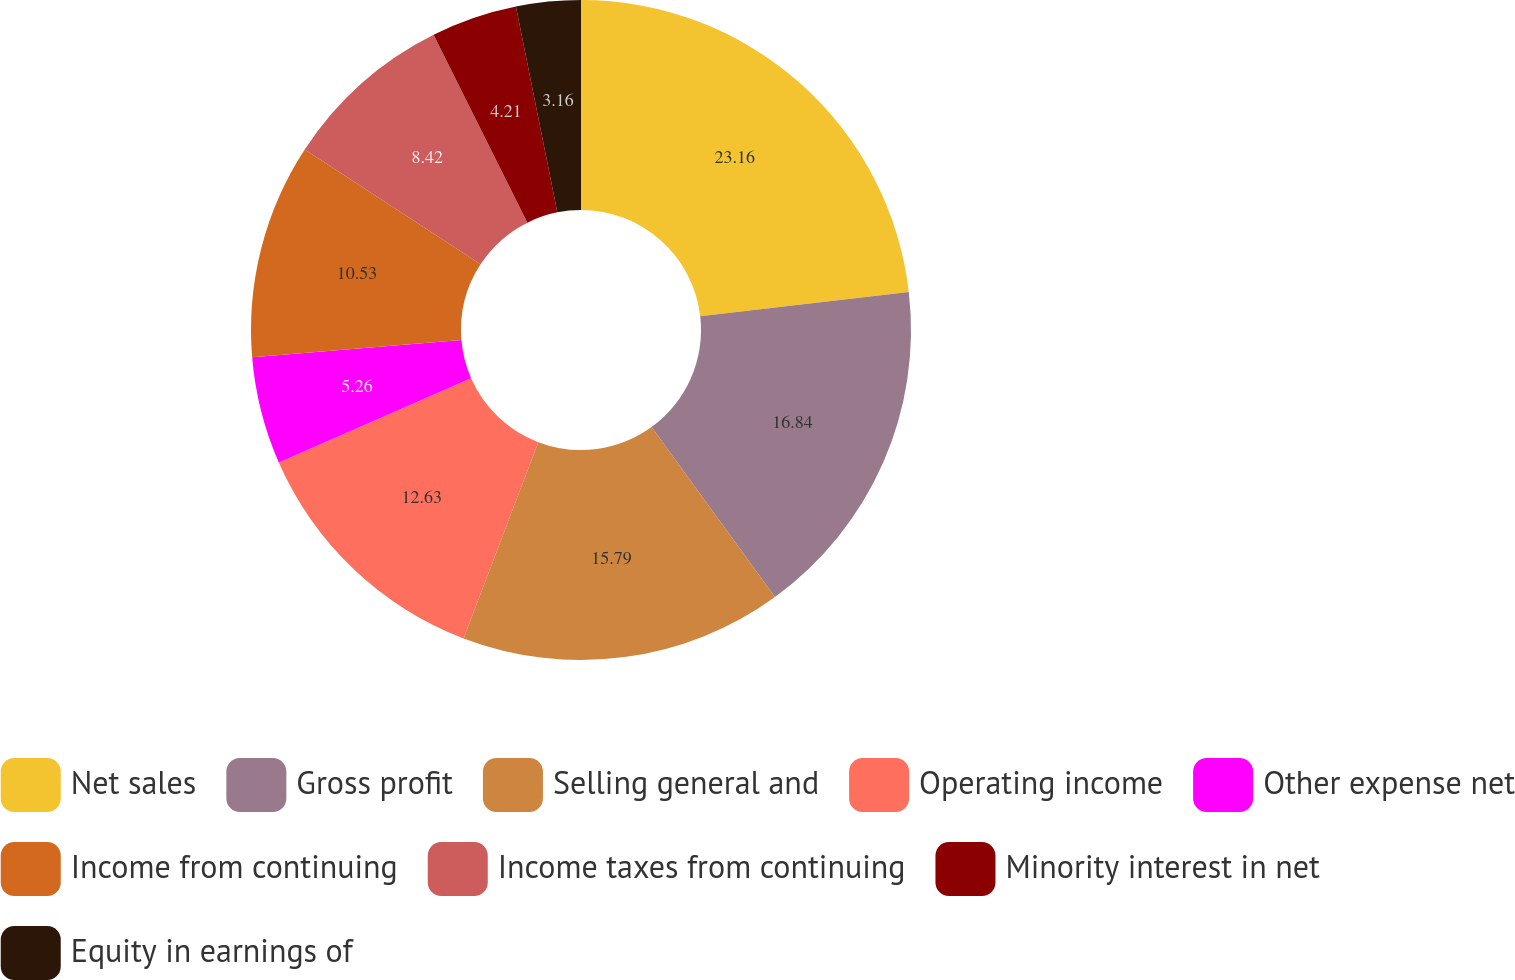Convert chart to OTSL. <chart><loc_0><loc_0><loc_500><loc_500><pie_chart><fcel>Net sales<fcel>Gross profit<fcel>Selling general and<fcel>Operating income<fcel>Other expense net<fcel>Income from continuing<fcel>Income taxes from continuing<fcel>Minority interest in net<fcel>Equity in earnings of<nl><fcel>23.16%<fcel>16.84%<fcel>15.79%<fcel>12.63%<fcel>5.26%<fcel>10.53%<fcel>8.42%<fcel>4.21%<fcel>3.16%<nl></chart> 